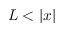Convert formula to latex. <formula><loc_0><loc_0><loc_500><loc_500>L < | x |</formula> 